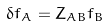<formula> <loc_0><loc_0><loc_500><loc_500>\delta f _ { A } = Z _ { A B } f _ { B }</formula> 